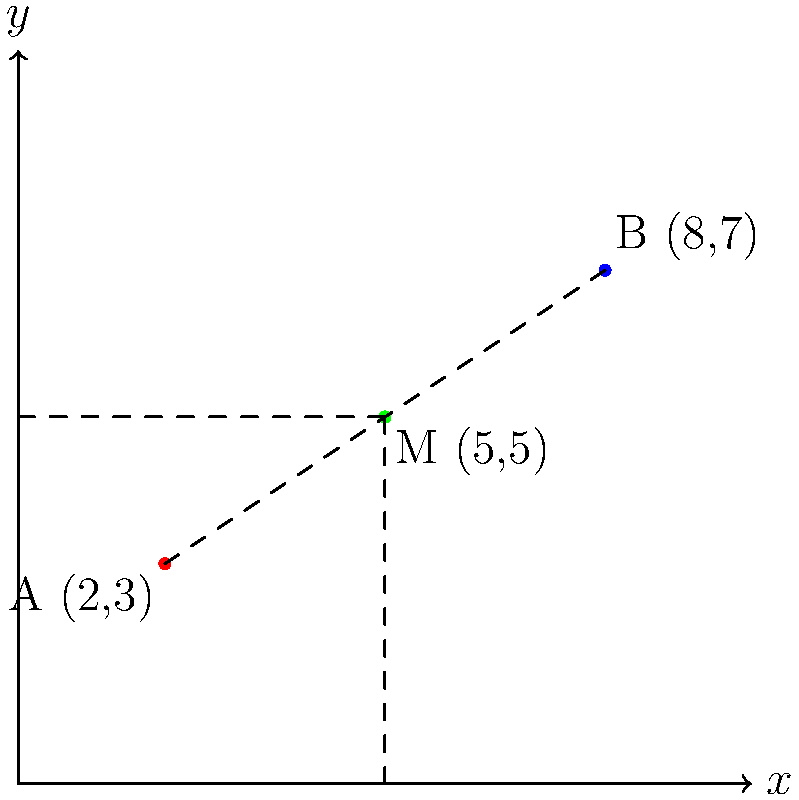On a city map using a coordinate system, two job sites are located at points A(2,3) and B(8,7). What are the coordinates of the midpoint M between these two locations? This information could be useful for planning a union meeting at a central location between the two sites. To find the midpoint M between two points A(x₁,y₁) and B(x₂,y₂), we use the midpoint formula:

$$ M = (\frac{x_1 + x_2}{2}, \frac{y_1 + y_2}{2}) $$

Given:
- Point A: (2,3)
- Point B: (8,7)

Step 1: Calculate the x-coordinate of the midpoint:
$$ x_M = \frac{x_1 + x_2}{2} = \frac{2 + 8}{2} = \frac{10}{2} = 5 $$

Step 2: Calculate the y-coordinate of the midpoint:
$$ y_M = \frac{y_1 + y_2}{2} = \frac{3 + 7}{2} = \frac{10}{2} = 5 $$

Step 3: Combine the results to get the midpoint coordinates:
$$ M = (5, 5) $$

This point (5,5) represents the location on the map that is equidistant from both job sites, making it an ideal meeting point for workers from both locations.
Answer: (5,5) 